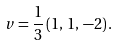Convert formula to latex. <formula><loc_0><loc_0><loc_500><loc_500>v = \frac { 1 } { 3 } \left ( 1 , \, 1 , \, - 2 \right ) .</formula> 